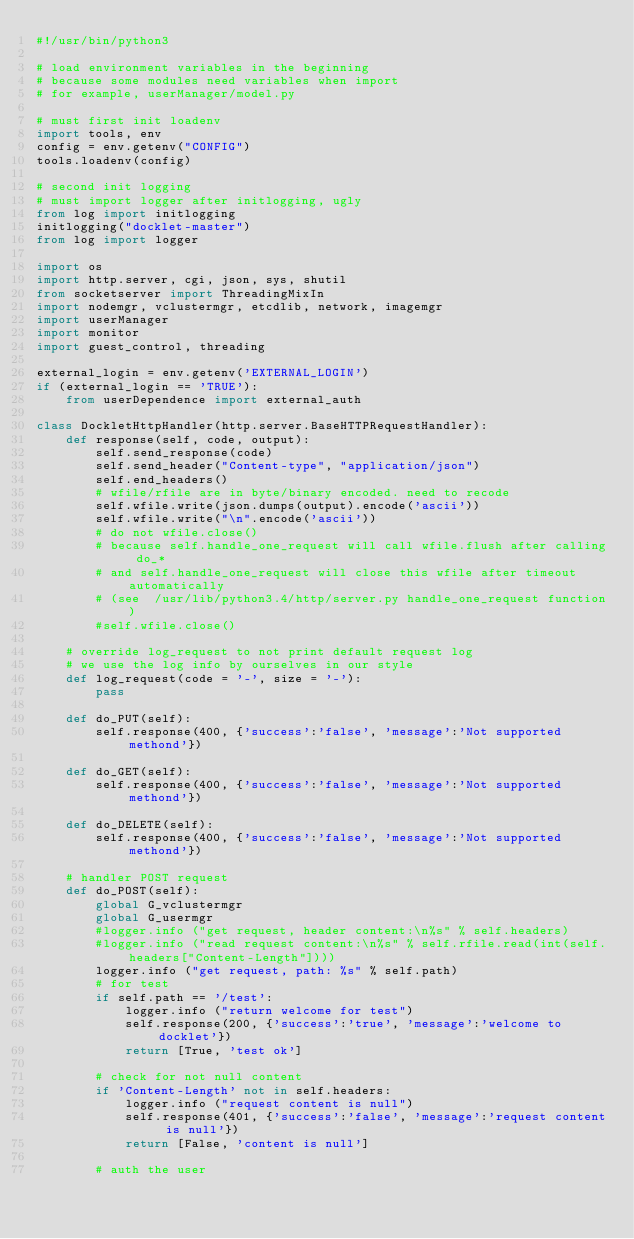Convert code to text. <code><loc_0><loc_0><loc_500><loc_500><_Python_>#!/usr/bin/python3

# load environment variables in the beginning
# because some modules need variables when import
# for example, userManager/model.py

# must first init loadenv
import tools, env
config = env.getenv("CONFIG")
tools.loadenv(config)

# second init logging
# must import logger after initlogging, ugly
from log import initlogging
initlogging("docklet-master")
from log import logger

import os
import http.server, cgi, json, sys, shutil
from socketserver import ThreadingMixIn
import nodemgr, vclustermgr, etcdlib, network, imagemgr
import userManager
import monitor
import guest_control, threading

external_login = env.getenv('EXTERNAL_LOGIN')
if (external_login == 'TRUE'):
    from userDependence import external_auth

class DockletHttpHandler(http.server.BaseHTTPRequestHandler):
    def response(self, code, output):
        self.send_response(code)
        self.send_header("Content-type", "application/json")
        self.end_headers()
        # wfile/rfile are in byte/binary encoded. need to recode
        self.wfile.write(json.dumps(output).encode('ascii'))
        self.wfile.write("\n".encode('ascii'))
        # do not wfile.close()
        # because self.handle_one_request will call wfile.flush after calling do_*
        # and self.handle_one_request will close this wfile after timeout automatically
        # (see  /usr/lib/python3.4/http/server.py handle_one_request function)
        #self.wfile.close()

    # override log_request to not print default request log
    # we use the log info by ourselves in our style
    def log_request(code = '-', size = '-'):
        pass

    def do_PUT(self):
        self.response(400, {'success':'false', 'message':'Not supported methond'})

    def do_GET(self):
        self.response(400, {'success':'false', 'message':'Not supported methond'})

    def do_DELETE(self):
        self.response(400, {'success':'false', 'message':'Not supported methond'})

    # handler POST request
    def do_POST(self):
        global G_vclustermgr
        global G_usermgr
        #logger.info ("get request, header content:\n%s" % self.headers)
        #logger.info ("read request content:\n%s" % self.rfile.read(int(self.headers["Content-Length"])))
        logger.info ("get request, path: %s" % self.path)
        # for test
        if self.path == '/test':
            logger.info ("return welcome for test")
            self.response(200, {'success':'true', 'message':'welcome to docklet'})
            return [True, 'test ok']

        # check for not null content
        if 'Content-Length' not in self.headers:
            logger.info ("request content is null")
            self.response(401, {'success':'false', 'message':'request content is null'})
            return [False, 'content is null']

        # auth the user</code> 